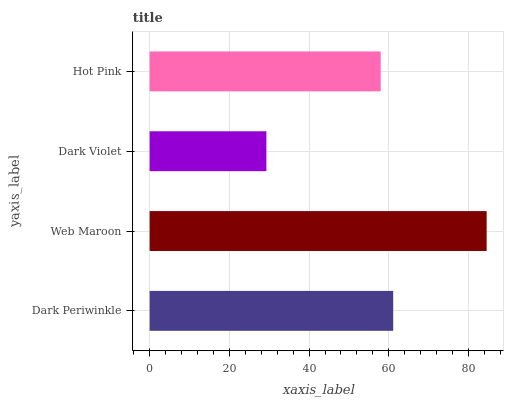Is Dark Violet the minimum?
Answer yes or no. Yes. Is Web Maroon the maximum?
Answer yes or no. Yes. Is Web Maroon the minimum?
Answer yes or no. No. Is Dark Violet the maximum?
Answer yes or no. No. Is Web Maroon greater than Dark Violet?
Answer yes or no. Yes. Is Dark Violet less than Web Maroon?
Answer yes or no. Yes. Is Dark Violet greater than Web Maroon?
Answer yes or no. No. Is Web Maroon less than Dark Violet?
Answer yes or no. No. Is Dark Periwinkle the high median?
Answer yes or no. Yes. Is Hot Pink the low median?
Answer yes or no. Yes. Is Web Maroon the high median?
Answer yes or no. No. Is Web Maroon the low median?
Answer yes or no. No. 